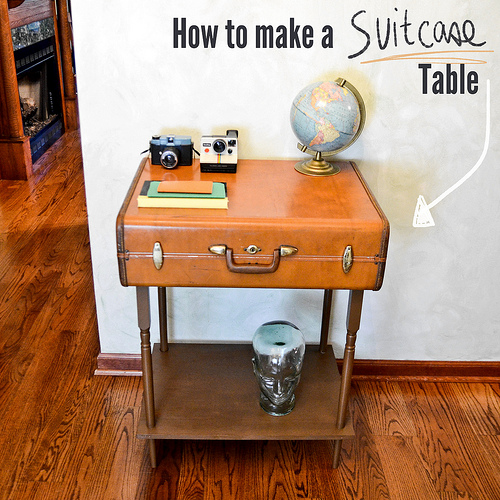<image>
Is the suitcase on the floor? No. The suitcase is not positioned on the floor. They may be near each other, but the suitcase is not supported by or resting on top of the floor. Is the camera to the left of the book? No. The camera is not to the left of the book. From this viewpoint, they have a different horizontal relationship. 